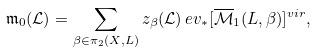<formula> <loc_0><loc_0><loc_500><loc_500>\mathfrak { m } _ { 0 } ( \mathcal { L } ) = \sum _ { \beta \in \pi _ { 2 } ( X , L ) } z _ { \beta } ( \mathcal { L } ) \, e v _ { * } [ \overline { \mathcal { M } } _ { 1 } ( L , \beta ) ] ^ { v i r } ,</formula> 